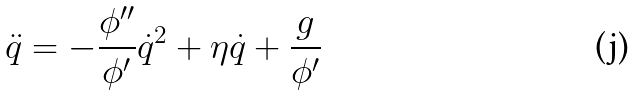Convert formula to latex. <formula><loc_0><loc_0><loc_500><loc_500>\ddot { q } = - \frac { \phi ^ { \prime \prime } } { \phi ^ { \prime } } \dot { q } ^ { 2 } + \eta \dot { q } + \frac { g } { \phi ^ { \prime } }</formula> 